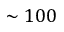Convert formula to latex. <formula><loc_0><loc_0><loc_500><loc_500>\sim 1 0 0</formula> 